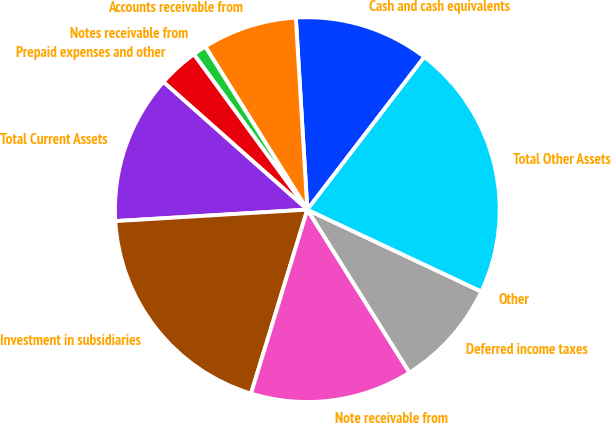Convert chart. <chart><loc_0><loc_0><loc_500><loc_500><pie_chart><fcel>Cash and cash equivalents<fcel>Accounts receivable from<fcel>Notes receivable from<fcel>Prepaid expenses and other<fcel>Total Current Assets<fcel>Investment in subsidiaries<fcel>Note receivable from<fcel>Deferred income taxes<fcel>Other<fcel>Total Other Assets<nl><fcel>11.36%<fcel>7.95%<fcel>1.14%<fcel>3.41%<fcel>12.5%<fcel>19.32%<fcel>13.64%<fcel>9.09%<fcel>0.0%<fcel>21.59%<nl></chart> 